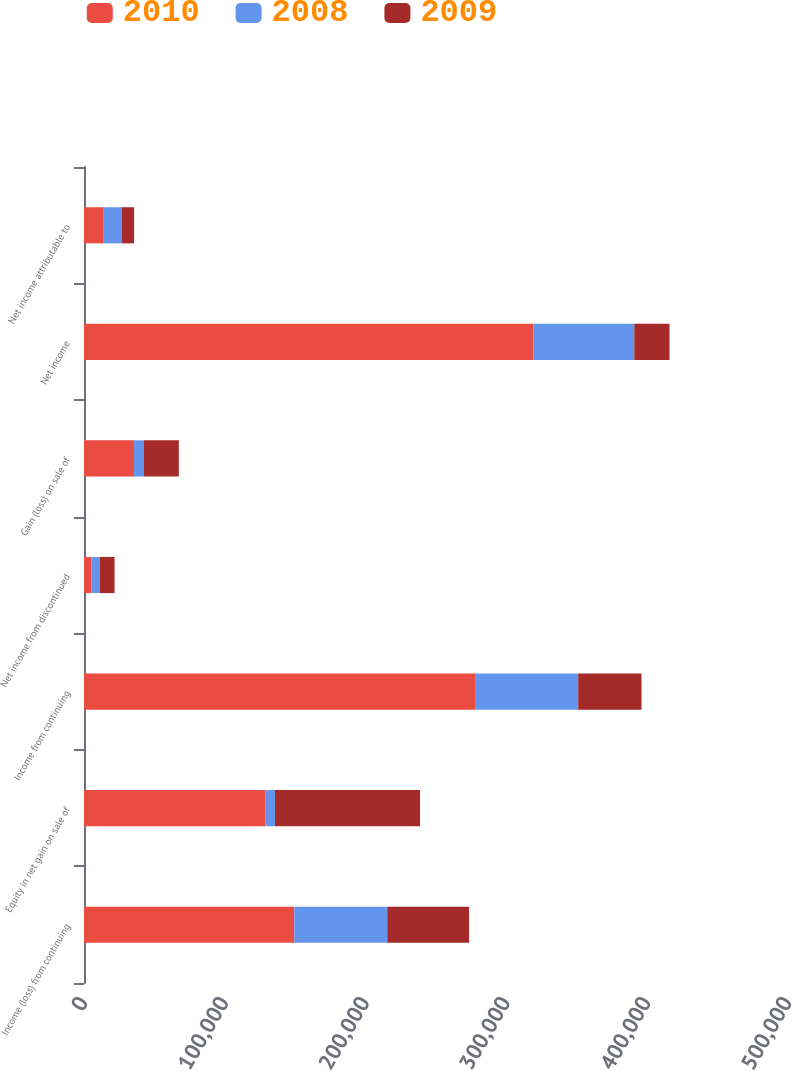Convert chart to OTSL. <chart><loc_0><loc_0><loc_500><loc_500><stacked_bar_chart><ecel><fcel>Income (loss) from continuing<fcel>Equity in net gain on sale of<fcel>Income from continuing<fcel>Net income from discontinued<fcel>Gain (loss) on sale of<fcel>Net income<fcel>Net income attributable to<nl><fcel>2010<fcel>149329<fcel>128922<fcel>278251<fcel>5420<fcel>35485<fcel>319156<fcel>14007<nl><fcel>2008<fcel>66041<fcel>6691<fcel>72732<fcel>5774<fcel>6841<fcel>71665<fcel>12900<nl><fcel>2009<fcel>58090<fcel>103056<fcel>44966<fcel>10509<fcel>25023<fcel>25023<fcel>8677<nl></chart> 